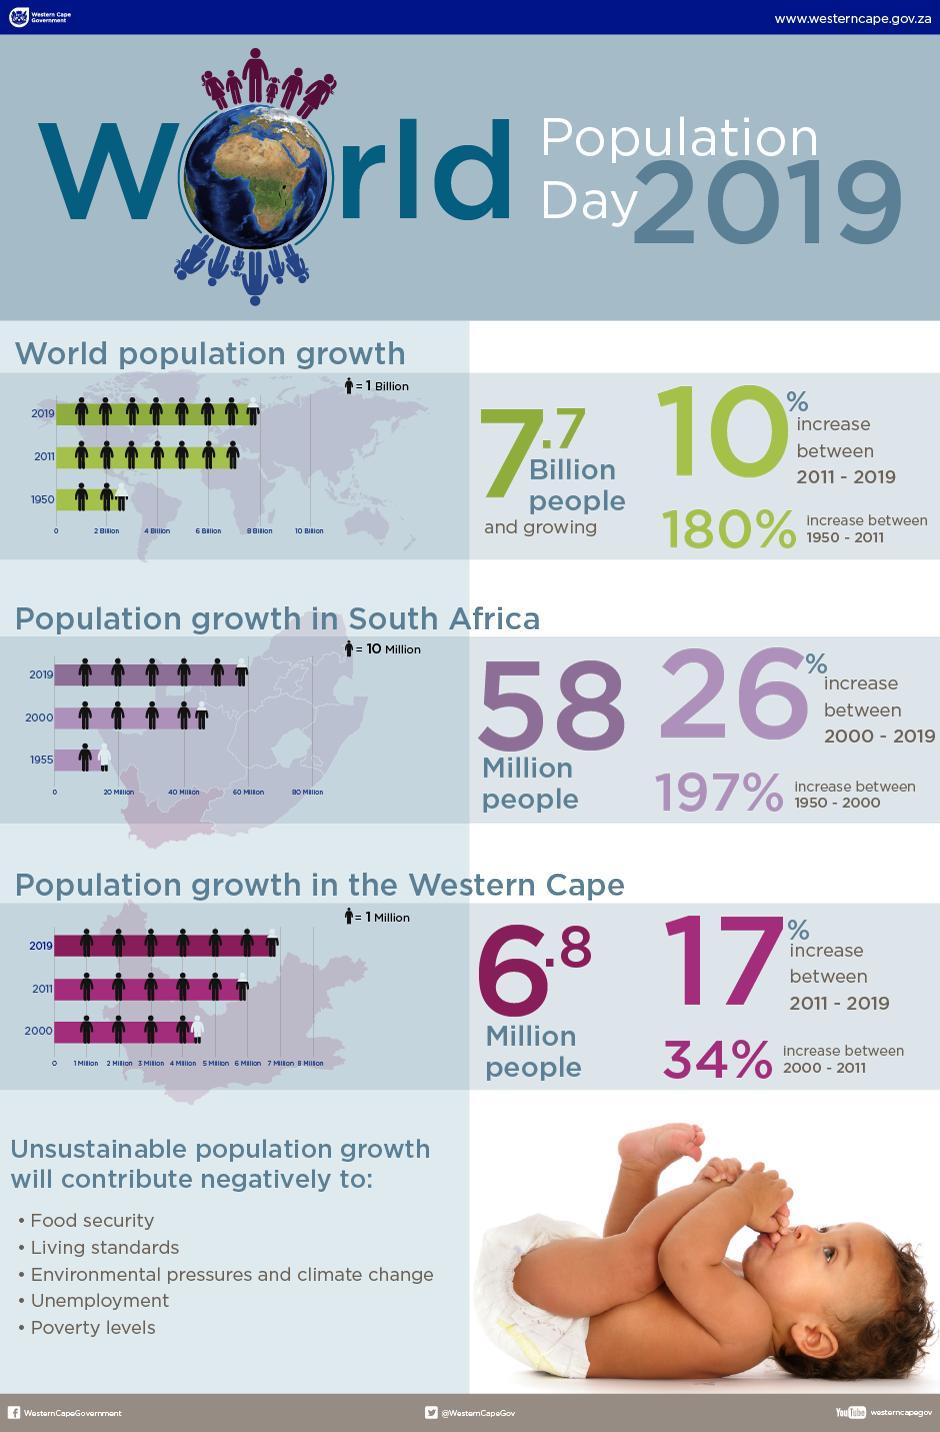What is the percentage growth in population in South Africa since 2000?
Answer the question with a short phrase. 26% What is the percentage increase in the world population growth since 1950? 180% How many negative points of unsustainable population growth are mentioned here? 5 What is the percentage growth in population in the Western Cape since 2011? 17% What can negatively affect the food security, living standards and poverty levels? Unsustainable population growth What is the population growth in South Africa in 2019? 58 million Which region has a higher population growth rate, the Western Cape or South Africa? South Africa What is the percentage increase in the world population growth since 2011? 10% What was the population growth in Western Cape in 2019? 6.8 million What is the word population growth in  2019? 7.7 billion What is the percentage growth in population in South Africa since 1950? 197% What is the percentage growth in population in the Western Cape since 1950? 34% 